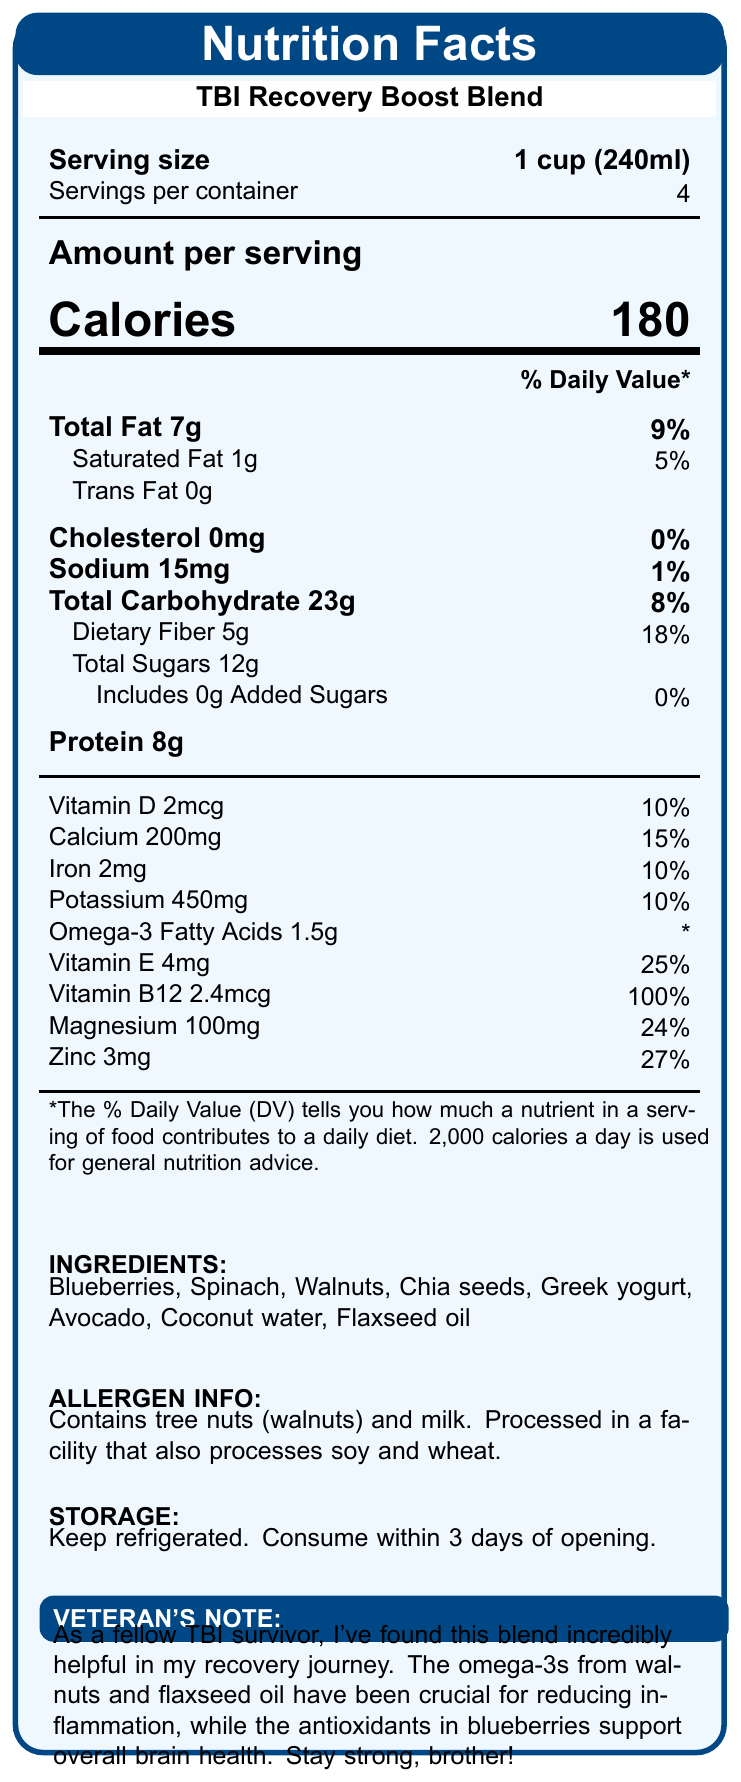what is the serving size of TBI Recovery Boost Blend? The serving size is clearly stated at the top of the document as "1 cup (240ml)".
Answer: 1 cup (240ml) how many servings are there per container? The document lists "Servings per container" as 4 right below the serving size information.
Answer: 4 how many calories are there per serving of the TBI Recovery Boost Blend? The document specifies the amount of calories per serving as 180 in the "Amount per serving" section.
Answer: 180 what percentage of daily Vitamin B12 does one serving provide? The document lists Vitamin B12 as providing 100% of the daily value per serving.
Answer: 100% what ingredients are included in the TBI Recovery Boost Blend? The ingredients section at the bottom of the document lists these items.
Answer: Blueberries, Spinach, Walnuts, Chia seeds, Greek yogurt, Avocado, Coconut water, Flaxseed oil which nutrient has the highest daily value percentage per serving? A. Vitamin D B. Zinc C. Dietary Fiber D. Magnesium E. Vitamin E Zinc is listed as providing 27% of the daily value per serving, which is the highest among the listed options.
Answer: B. Zinc how much protein is in each serving? The document specifies that each serving contains 8g of protein.
Answer: 8g does the TBI Recovery Boost Blend contain any added sugars? The document states that it includes 0g added sugars.
Answer: No how much Vitamin D is there per serving? A. 1mcg B. 2mcg C. 4mcg D. 2.4mcg The document specifies that there are 2mcg of Vitamin D per serving.
Answer: B. 2mcg is the product suitable for individuals with tree nut allergies? The allergen info section states that the product contains tree nuts (walnuts).
Answer: No summarize the main idea of the TBI Recovery Boost Blend's nutrition label. This summary focuses on the key details listed in the document, including the product's purpose, nutritional content, and additional notes.
Answer: The TBI Recovery Boost Blend is a brain-boosting drink designed for TBI recovery, providing various nutrients in each 1-cup serving (e.g., vitamins, minerals, omega-3 fatty acids). It has a veteran's note highlighting its benefits for reducing inflammation and supporting brain health. The allergen information and storage instructions are also included. what is the source of the omega-3 fatty acids in the drink? The veteran's note section mentions that the omega-3s come from walnuts and flaxseed oil.
Answer: Walnuts and Flaxseed oil how much dietary fiber does one serving provide? The document specifies that one serving contains 5g of dietary fiber.
Answer: 5g where should the TBI Recovery Boost Blend be stored after opening? The storage instructions at the bottom of the document provide this information.
Answer: Keep refrigerated. Consume within 3 days of opening. can you determine the price of the TBI Recovery Boost Blend from the document? The document does not provide any information regarding the price of the product.
Answer: Not enough information 